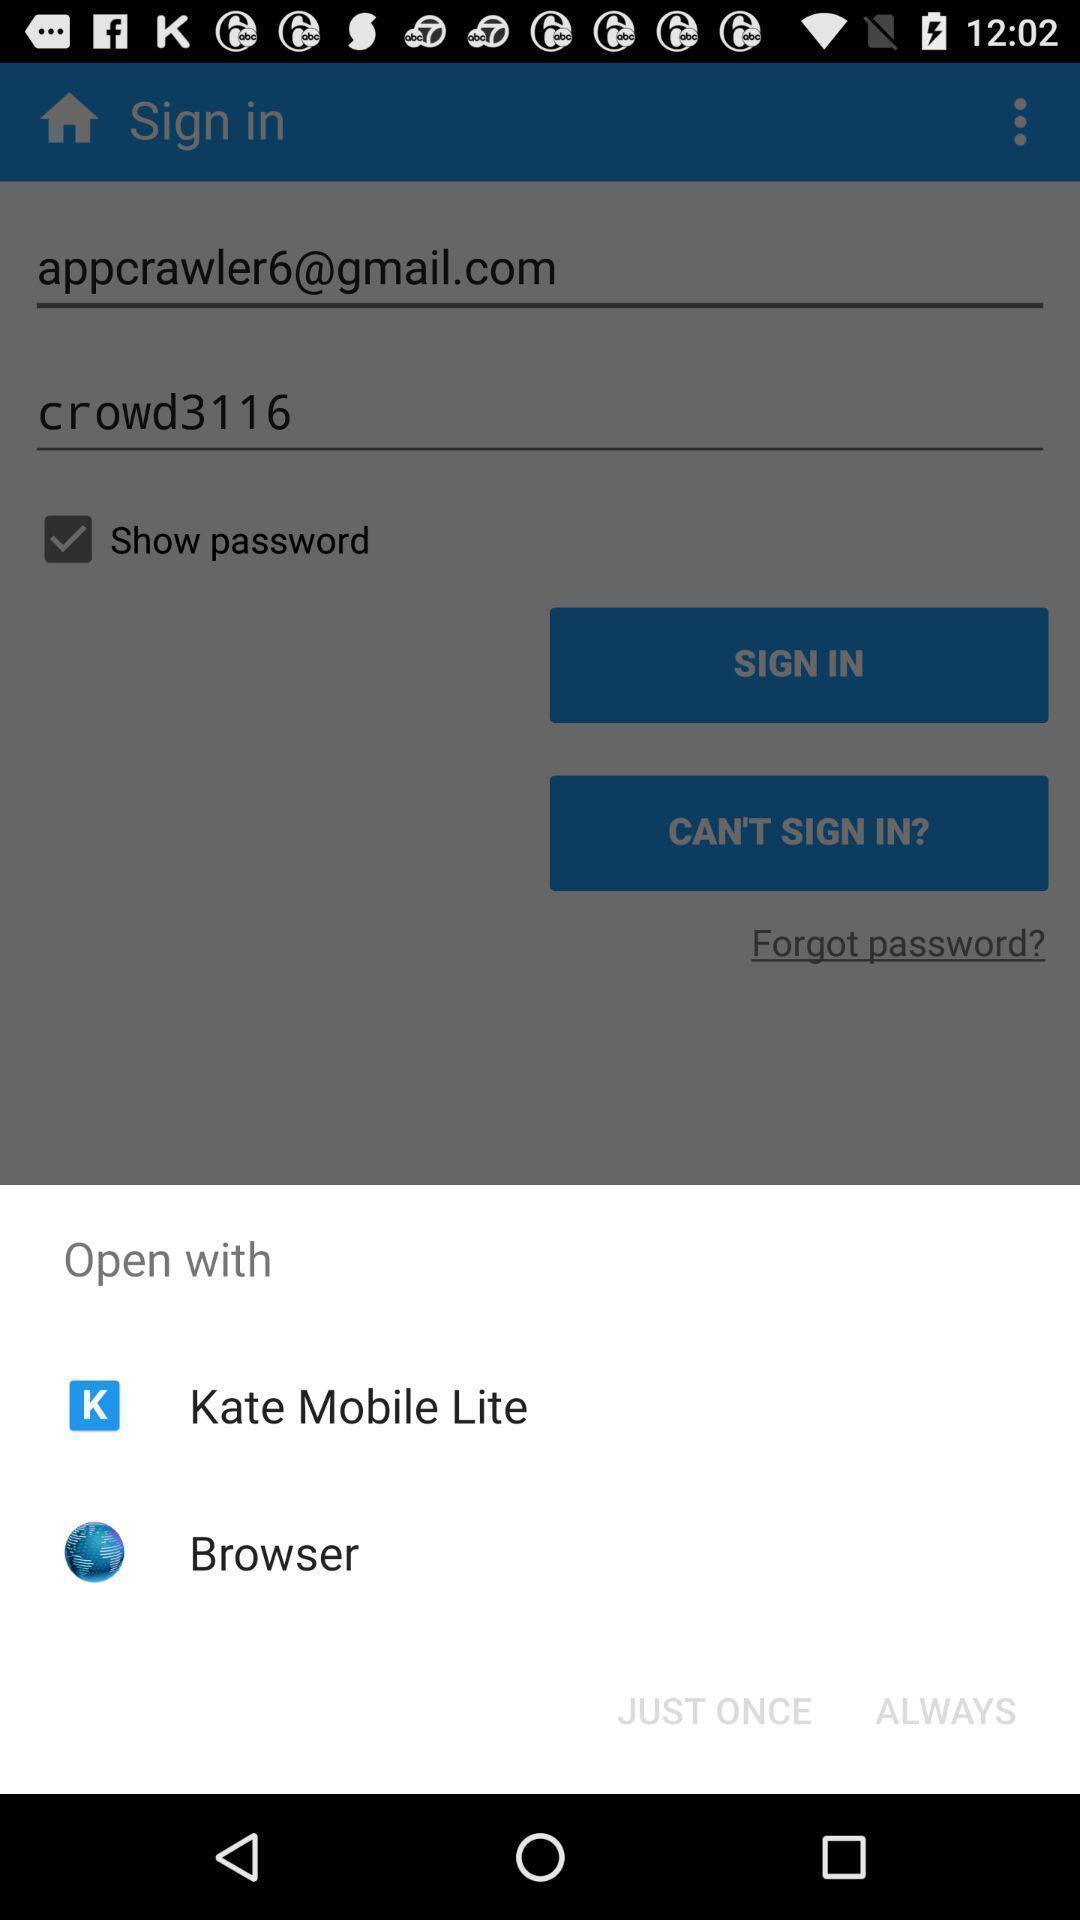Summarize the information in this screenshot. Pop-up for showing different options for open. 